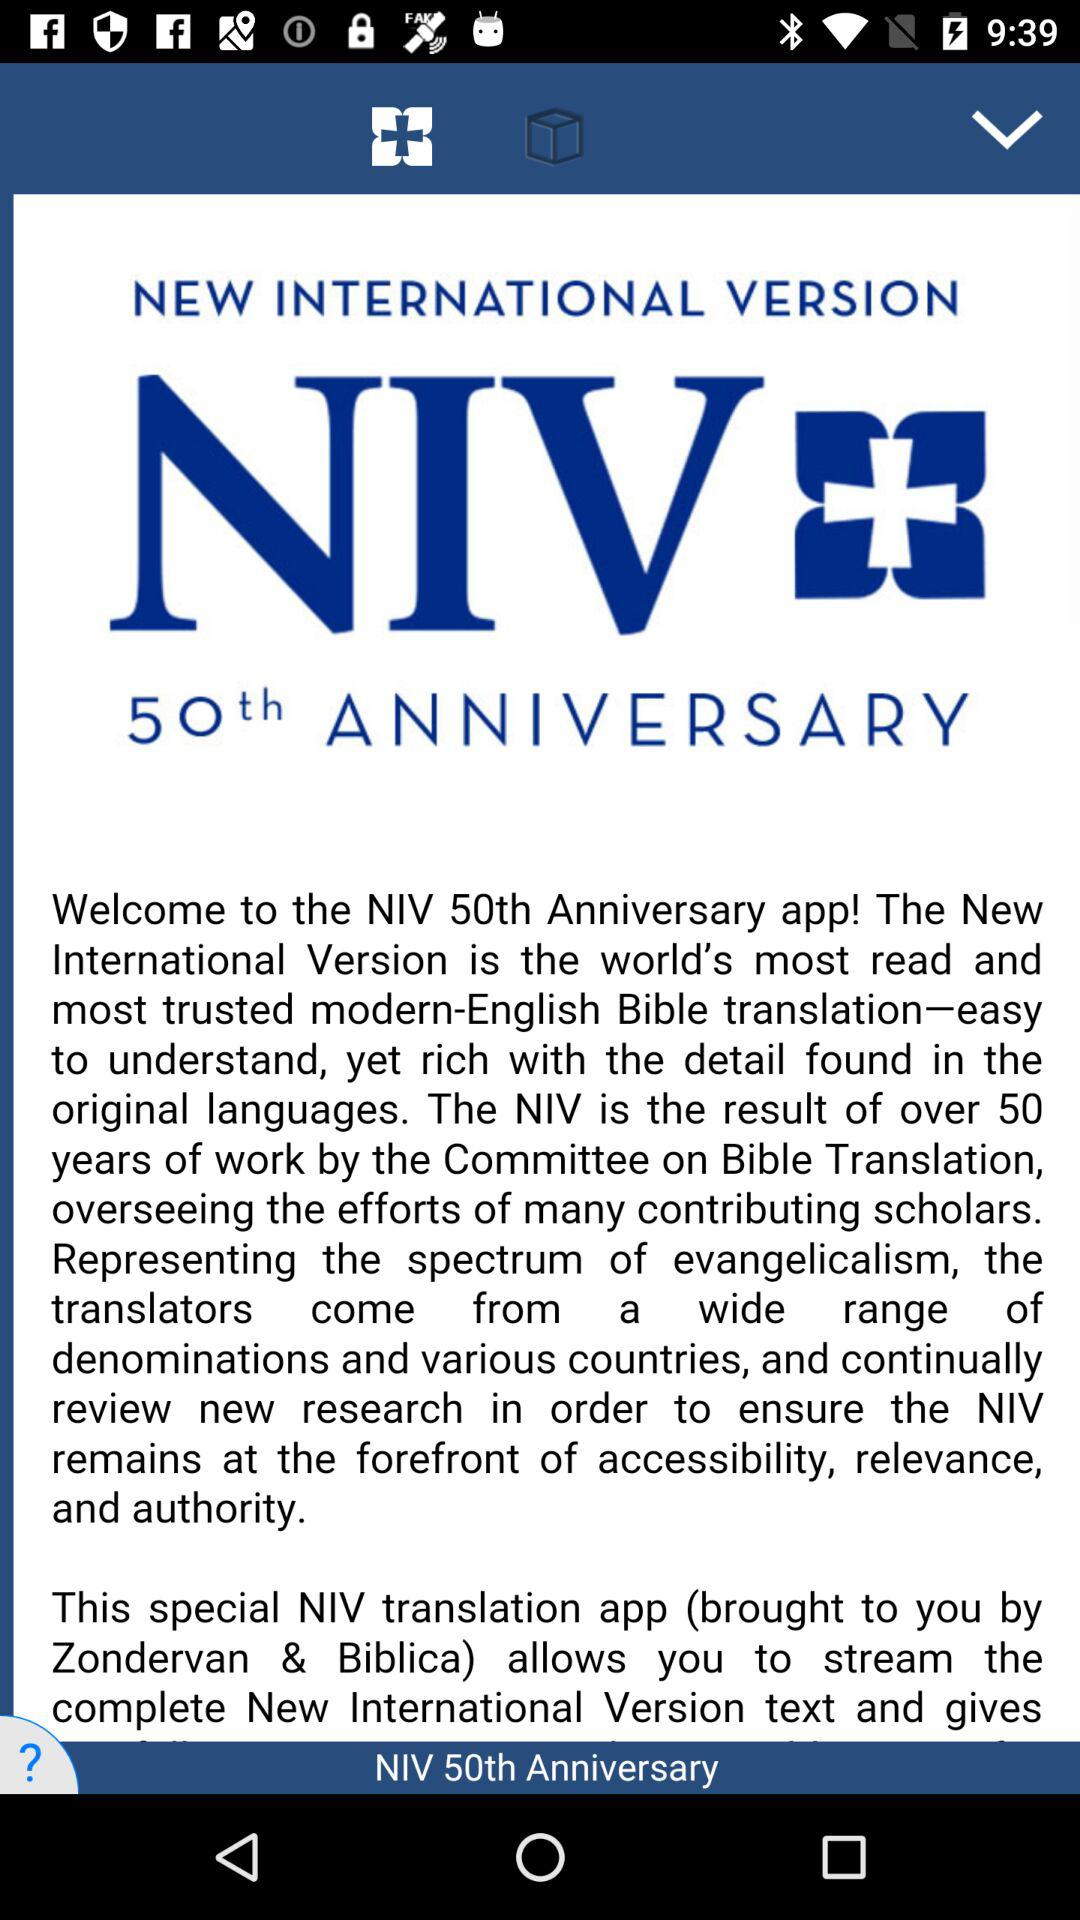What is the name of the application? The name of the application is "NIV 50th Anniversary". 